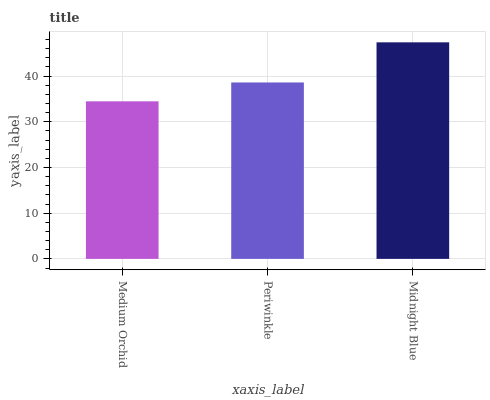Is Medium Orchid the minimum?
Answer yes or no. Yes. Is Midnight Blue the maximum?
Answer yes or no. Yes. Is Periwinkle the minimum?
Answer yes or no. No. Is Periwinkle the maximum?
Answer yes or no. No. Is Periwinkle greater than Medium Orchid?
Answer yes or no. Yes. Is Medium Orchid less than Periwinkle?
Answer yes or no. Yes. Is Medium Orchid greater than Periwinkle?
Answer yes or no. No. Is Periwinkle less than Medium Orchid?
Answer yes or no. No. Is Periwinkle the high median?
Answer yes or no. Yes. Is Periwinkle the low median?
Answer yes or no. Yes. Is Midnight Blue the high median?
Answer yes or no. No. Is Midnight Blue the low median?
Answer yes or no. No. 